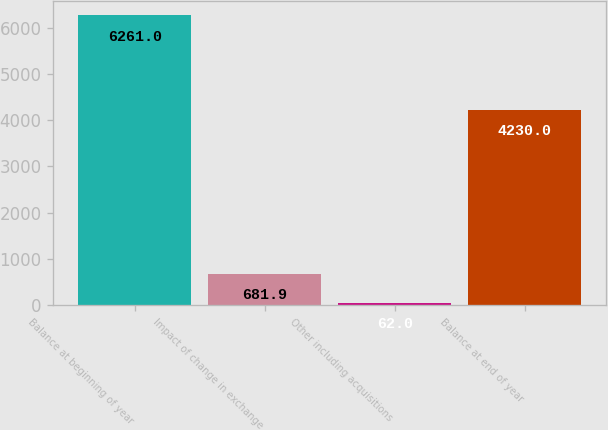Convert chart. <chart><loc_0><loc_0><loc_500><loc_500><bar_chart><fcel>Balance at beginning of year<fcel>Impact of change in exchange<fcel>Other including acquisitions<fcel>Balance at end of year<nl><fcel>6261<fcel>681.9<fcel>62<fcel>4230<nl></chart> 